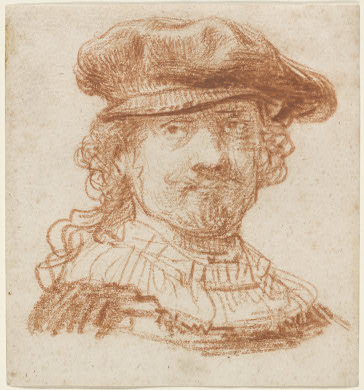Can you describe the main features of this image for me? The image features a portrait of a man, rendered in red chalk which highlights the warm, earthy undertones of the paper. His attire includes a flamboyant ruff collar and a stylish hat, which are indicative of the fashion trends during the Baroque period. The drawing technique utilized here exploits loose strokes and a visible array of hatching and cross-hatching, imparting both texture and depth, typical of Baroque artwork aimed to produce vivid expressions and dramatic flair. The man's slight smile and engaging gaze hint at a personality that is both intriguing and inviting, capturing an essence that extends beyond mere portraiture to touch on the persona of the subject. 